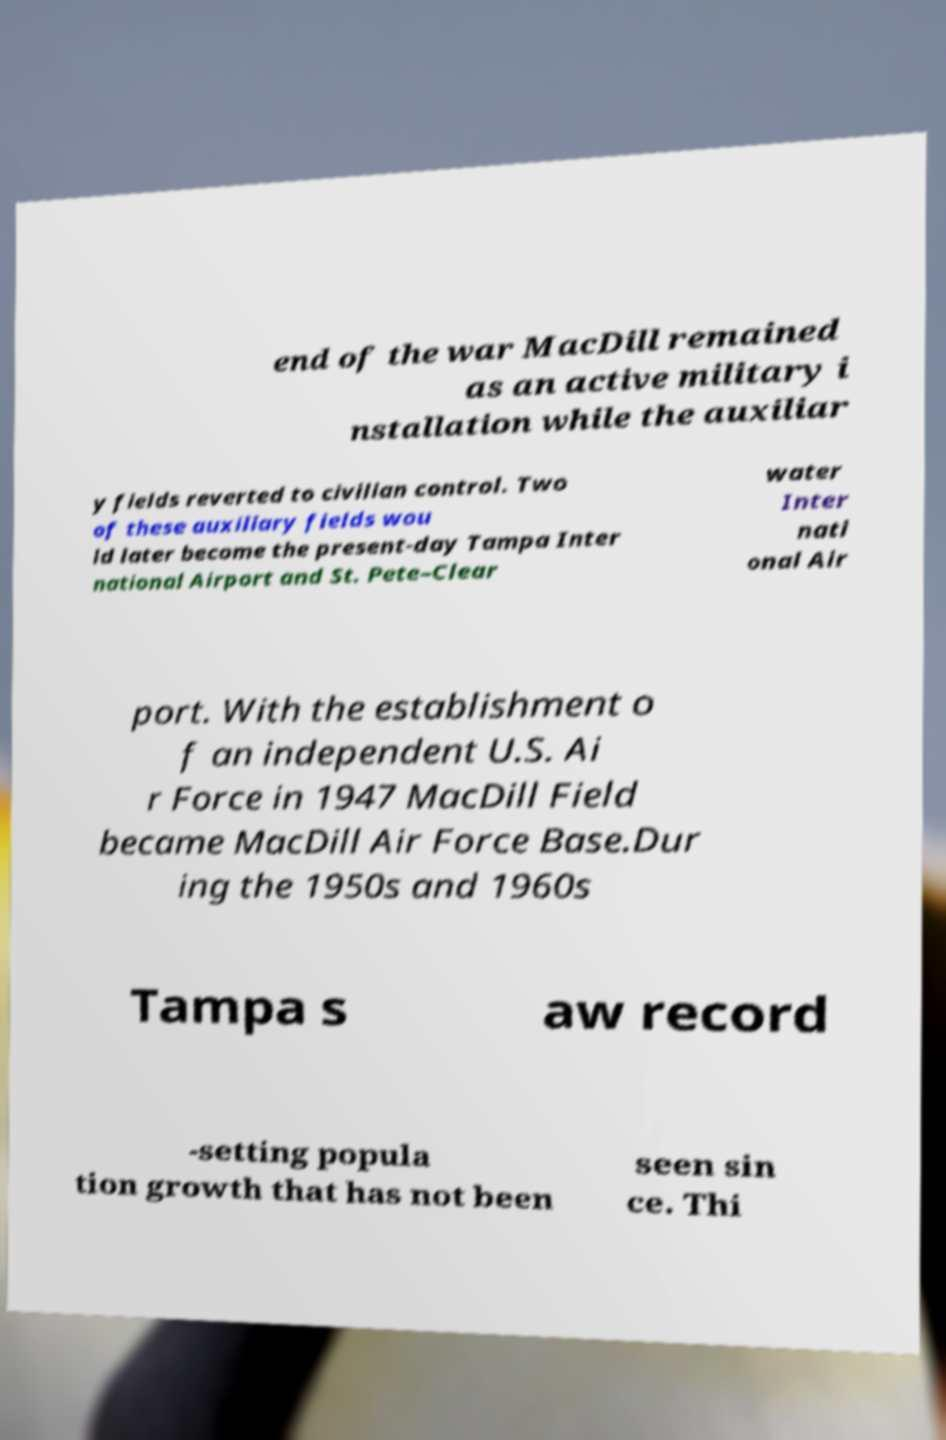There's text embedded in this image that I need extracted. Can you transcribe it verbatim? end of the war MacDill remained as an active military i nstallation while the auxiliar y fields reverted to civilian control. Two of these auxiliary fields wou ld later become the present-day Tampa Inter national Airport and St. Pete–Clear water Inter nati onal Air port. With the establishment o f an independent U.S. Ai r Force in 1947 MacDill Field became MacDill Air Force Base.Dur ing the 1950s and 1960s Tampa s aw record -setting popula tion growth that has not been seen sin ce. Thi 